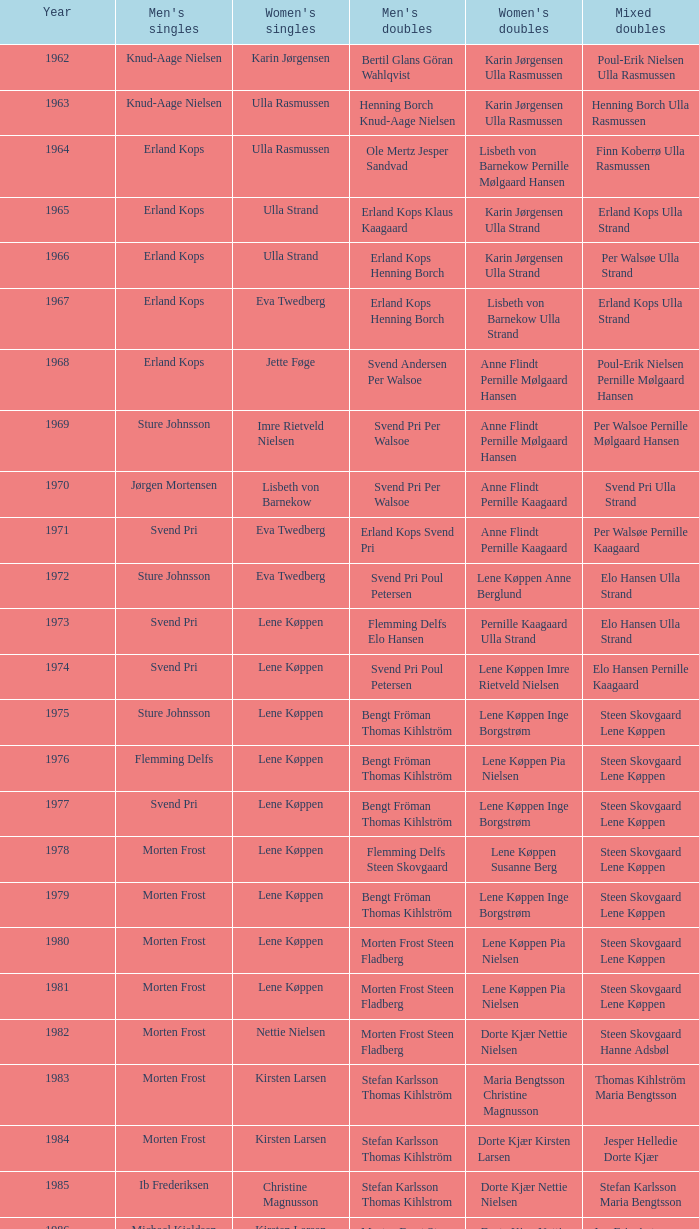Who won the men's doubles the year Pernille Nedergaard won the women's singles? Thomas Stuer-Lauridsen Max Gandrup. 